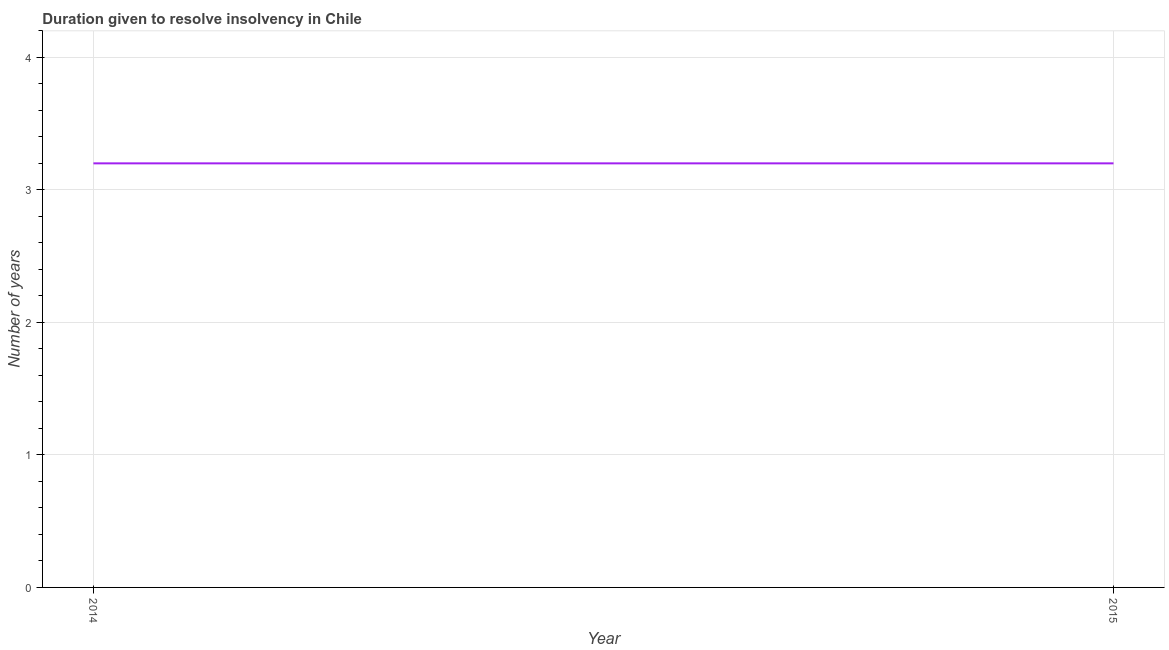Across all years, what is the maximum number of years to resolve insolvency?
Make the answer very short. 3.2. In which year was the number of years to resolve insolvency maximum?
Make the answer very short. 2014. In which year was the number of years to resolve insolvency minimum?
Offer a very short reply. 2014. What is the difference between the number of years to resolve insolvency in 2014 and 2015?
Provide a succinct answer. 0. What is the median number of years to resolve insolvency?
Offer a very short reply. 3.2. In how many years, is the number of years to resolve insolvency greater than 3.4 ?
Give a very brief answer. 0. Do a majority of the years between 2015 and 2014 (inclusive) have number of years to resolve insolvency greater than 3 ?
Offer a terse response. No. What is the ratio of the number of years to resolve insolvency in 2014 to that in 2015?
Your answer should be compact. 1. Is the number of years to resolve insolvency in 2014 less than that in 2015?
Your response must be concise. No. In how many years, is the number of years to resolve insolvency greater than the average number of years to resolve insolvency taken over all years?
Your response must be concise. 0. How many lines are there?
Provide a succinct answer. 1. Are the values on the major ticks of Y-axis written in scientific E-notation?
Give a very brief answer. No. Does the graph contain any zero values?
Give a very brief answer. No. What is the title of the graph?
Provide a short and direct response. Duration given to resolve insolvency in Chile. What is the label or title of the X-axis?
Your answer should be compact. Year. What is the label or title of the Y-axis?
Provide a succinct answer. Number of years. What is the Number of years in 2015?
Keep it short and to the point. 3.2. What is the difference between the Number of years in 2014 and 2015?
Offer a terse response. 0. 